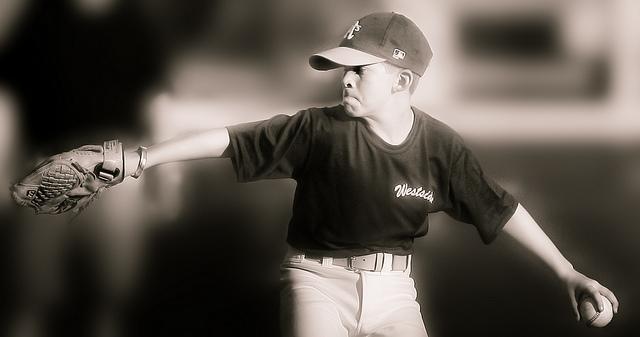Is he tagging someone out?
Give a very brief answer. No. What kind of cap is the man wearing in the image?
Be succinct. Baseball. What does the shirt say?
Concise answer only. Westside. What sport is the boy playing?
Concise answer only. Baseball. Does this person look serious?
Give a very brief answer. Yes. 